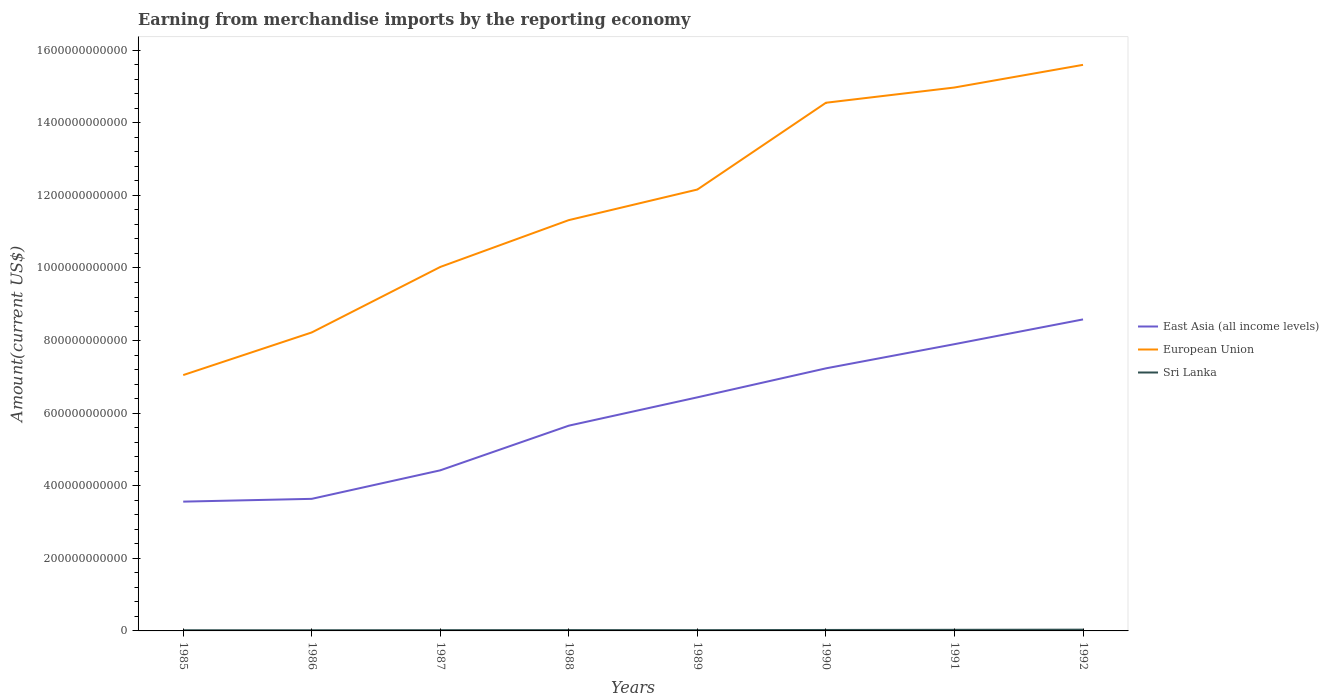Does the line corresponding to East Asia (all income levels) intersect with the line corresponding to Sri Lanka?
Keep it short and to the point. No. Is the number of lines equal to the number of legend labels?
Make the answer very short. Yes. Across all years, what is the maximum amount earned from merchandise imports in Sri Lanka?
Your response must be concise. 1.83e+09. What is the total amount earned from merchandise imports in East Asia (all income levels) in the graph?
Provide a succinct answer. -8.63e+1. What is the difference between the highest and the second highest amount earned from merchandise imports in Sri Lanka?
Provide a short and direct response. 1.64e+09. What is the difference between the highest and the lowest amount earned from merchandise imports in Sri Lanka?
Make the answer very short. 3. Is the amount earned from merchandise imports in East Asia (all income levels) strictly greater than the amount earned from merchandise imports in Sri Lanka over the years?
Ensure brevity in your answer.  No. How many lines are there?
Provide a succinct answer. 3. What is the difference between two consecutive major ticks on the Y-axis?
Provide a succinct answer. 2.00e+11. Does the graph contain any zero values?
Your response must be concise. No. Does the graph contain grids?
Keep it short and to the point. No. What is the title of the graph?
Offer a terse response. Earning from merchandise imports by the reporting economy. What is the label or title of the X-axis?
Make the answer very short. Years. What is the label or title of the Y-axis?
Offer a very short reply. Amount(current US$). What is the Amount(current US$) in East Asia (all income levels) in 1985?
Your answer should be compact. 3.56e+11. What is the Amount(current US$) of European Union in 1985?
Your response must be concise. 7.05e+11. What is the Amount(current US$) of Sri Lanka in 1985?
Provide a succinct answer. 1.83e+09. What is the Amount(current US$) in East Asia (all income levels) in 1986?
Give a very brief answer. 3.64e+11. What is the Amount(current US$) in European Union in 1986?
Your response must be concise. 8.22e+11. What is the Amount(current US$) of Sri Lanka in 1986?
Keep it short and to the point. 1.83e+09. What is the Amount(current US$) of East Asia (all income levels) in 1987?
Make the answer very short. 4.43e+11. What is the Amount(current US$) in European Union in 1987?
Provide a short and direct response. 1.00e+12. What is the Amount(current US$) of Sri Lanka in 1987?
Your answer should be very brief. 2.06e+09. What is the Amount(current US$) of East Asia (all income levels) in 1988?
Provide a succinct answer. 5.66e+11. What is the Amount(current US$) in European Union in 1988?
Your answer should be compact. 1.13e+12. What is the Amount(current US$) in Sri Lanka in 1988?
Provide a short and direct response. 2.28e+09. What is the Amount(current US$) in East Asia (all income levels) in 1989?
Make the answer very short. 6.44e+11. What is the Amount(current US$) in European Union in 1989?
Your answer should be compact. 1.22e+12. What is the Amount(current US$) in Sri Lanka in 1989?
Offer a very short reply. 2.09e+09. What is the Amount(current US$) of East Asia (all income levels) in 1990?
Keep it short and to the point. 7.23e+11. What is the Amount(current US$) in European Union in 1990?
Provide a short and direct response. 1.46e+12. What is the Amount(current US$) of Sri Lanka in 1990?
Make the answer very short. 2.64e+09. What is the Amount(current US$) in East Asia (all income levels) in 1991?
Offer a very short reply. 7.90e+11. What is the Amount(current US$) in European Union in 1991?
Your response must be concise. 1.50e+12. What is the Amount(current US$) in Sri Lanka in 1991?
Your answer should be compact. 3.06e+09. What is the Amount(current US$) of East Asia (all income levels) in 1992?
Your response must be concise. 8.58e+11. What is the Amount(current US$) in European Union in 1992?
Your answer should be compact. 1.56e+12. What is the Amount(current US$) in Sri Lanka in 1992?
Provide a succinct answer. 3.47e+09. Across all years, what is the maximum Amount(current US$) of East Asia (all income levels)?
Keep it short and to the point. 8.58e+11. Across all years, what is the maximum Amount(current US$) of European Union?
Offer a very short reply. 1.56e+12. Across all years, what is the maximum Amount(current US$) in Sri Lanka?
Your answer should be compact. 3.47e+09. Across all years, what is the minimum Amount(current US$) of East Asia (all income levels)?
Ensure brevity in your answer.  3.56e+11. Across all years, what is the minimum Amount(current US$) of European Union?
Provide a succinct answer. 7.05e+11. Across all years, what is the minimum Amount(current US$) of Sri Lanka?
Give a very brief answer. 1.83e+09. What is the total Amount(current US$) in East Asia (all income levels) in the graph?
Give a very brief answer. 4.74e+12. What is the total Amount(current US$) of European Union in the graph?
Offer a terse response. 9.39e+12. What is the total Amount(current US$) of Sri Lanka in the graph?
Make the answer very short. 1.93e+1. What is the difference between the Amount(current US$) in East Asia (all income levels) in 1985 and that in 1986?
Keep it short and to the point. -7.68e+09. What is the difference between the Amount(current US$) in European Union in 1985 and that in 1986?
Ensure brevity in your answer.  -1.17e+11. What is the difference between the Amount(current US$) in Sri Lanka in 1985 and that in 1986?
Give a very brief answer. 2.37e+06. What is the difference between the Amount(current US$) in East Asia (all income levels) in 1985 and that in 1987?
Ensure brevity in your answer.  -8.63e+1. What is the difference between the Amount(current US$) of European Union in 1985 and that in 1987?
Your answer should be compact. -2.98e+11. What is the difference between the Amount(current US$) of Sri Lanka in 1985 and that in 1987?
Offer a terse response. -2.25e+08. What is the difference between the Amount(current US$) of East Asia (all income levels) in 1985 and that in 1988?
Keep it short and to the point. -2.09e+11. What is the difference between the Amount(current US$) of European Union in 1985 and that in 1988?
Your response must be concise. -4.27e+11. What is the difference between the Amount(current US$) of Sri Lanka in 1985 and that in 1988?
Provide a short and direct response. -4.47e+08. What is the difference between the Amount(current US$) in East Asia (all income levels) in 1985 and that in 1989?
Offer a terse response. -2.87e+11. What is the difference between the Amount(current US$) of European Union in 1985 and that in 1989?
Your answer should be very brief. -5.11e+11. What is the difference between the Amount(current US$) of Sri Lanka in 1985 and that in 1989?
Give a very brief answer. -2.56e+08. What is the difference between the Amount(current US$) in East Asia (all income levels) in 1985 and that in 1990?
Ensure brevity in your answer.  -3.67e+11. What is the difference between the Amount(current US$) in European Union in 1985 and that in 1990?
Keep it short and to the point. -7.50e+11. What is the difference between the Amount(current US$) of Sri Lanka in 1985 and that in 1990?
Give a very brief answer. -8.05e+08. What is the difference between the Amount(current US$) of East Asia (all income levels) in 1985 and that in 1991?
Ensure brevity in your answer.  -4.34e+11. What is the difference between the Amount(current US$) of European Union in 1985 and that in 1991?
Offer a terse response. -7.92e+11. What is the difference between the Amount(current US$) in Sri Lanka in 1985 and that in 1991?
Offer a very short reply. -1.23e+09. What is the difference between the Amount(current US$) in East Asia (all income levels) in 1985 and that in 1992?
Your answer should be compact. -5.02e+11. What is the difference between the Amount(current US$) in European Union in 1985 and that in 1992?
Make the answer very short. -8.55e+11. What is the difference between the Amount(current US$) in Sri Lanka in 1985 and that in 1992?
Keep it short and to the point. -1.64e+09. What is the difference between the Amount(current US$) of East Asia (all income levels) in 1986 and that in 1987?
Give a very brief answer. -7.86e+1. What is the difference between the Amount(current US$) in European Union in 1986 and that in 1987?
Your answer should be compact. -1.80e+11. What is the difference between the Amount(current US$) of Sri Lanka in 1986 and that in 1987?
Your response must be concise. -2.27e+08. What is the difference between the Amount(current US$) of East Asia (all income levels) in 1986 and that in 1988?
Offer a terse response. -2.02e+11. What is the difference between the Amount(current US$) of European Union in 1986 and that in 1988?
Offer a terse response. -3.10e+11. What is the difference between the Amount(current US$) in Sri Lanka in 1986 and that in 1988?
Your answer should be very brief. -4.49e+08. What is the difference between the Amount(current US$) of East Asia (all income levels) in 1986 and that in 1989?
Provide a short and direct response. -2.80e+11. What is the difference between the Amount(current US$) of European Union in 1986 and that in 1989?
Offer a terse response. -3.94e+11. What is the difference between the Amount(current US$) in Sri Lanka in 1986 and that in 1989?
Offer a very short reply. -2.58e+08. What is the difference between the Amount(current US$) in East Asia (all income levels) in 1986 and that in 1990?
Ensure brevity in your answer.  -3.60e+11. What is the difference between the Amount(current US$) of European Union in 1986 and that in 1990?
Offer a very short reply. -6.33e+11. What is the difference between the Amount(current US$) of Sri Lanka in 1986 and that in 1990?
Give a very brief answer. -8.07e+08. What is the difference between the Amount(current US$) in East Asia (all income levels) in 1986 and that in 1991?
Make the answer very short. -4.26e+11. What is the difference between the Amount(current US$) of European Union in 1986 and that in 1991?
Give a very brief answer. -6.75e+11. What is the difference between the Amount(current US$) in Sri Lanka in 1986 and that in 1991?
Provide a short and direct response. -1.23e+09. What is the difference between the Amount(current US$) in East Asia (all income levels) in 1986 and that in 1992?
Provide a succinct answer. -4.94e+11. What is the difference between the Amount(current US$) of European Union in 1986 and that in 1992?
Your response must be concise. -7.37e+11. What is the difference between the Amount(current US$) in Sri Lanka in 1986 and that in 1992?
Your response must be concise. -1.64e+09. What is the difference between the Amount(current US$) in East Asia (all income levels) in 1987 and that in 1988?
Your answer should be very brief. -1.23e+11. What is the difference between the Amount(current US$) of European Union in 1987 and that in 1988?
Your answer should be compact. -1.29e+11. What is the difference between the Amount(current US$) in Sri Lanka in 1987 and that in 1988?
Offer a terse response. -2.22e+08. What is the difference between the Amount(current US$) of East Asia (all income levels) in 1987 and that in 1989?
Your response must be concise. -2.01e+11. What is the difference between the Amount(current US$) in European Union in 1987 and that in 1989?
Make the answer very short. -2.13e+11. What is the difference between the Amount(current US$) in Sri Lanka in 1987 and that in 1989?
Give a very brief answer. -3.11e+07. What is the difference between the Amount(current US$) in East Asia (all income levels) in 1987 and that in 1990?
Keep it short and to the point. -2.81e+11. What is the difference between the Amount(current US$) in European Union in 1987 and that in 1990?
Ensure brevity in your answer.  -4.52e+11. What is the difference between the Amount(current US$) in Sri Lanka in 1987 and that in 1990?
Make the answer very short. -5.80e+08. What is the difference between the Amount(current US$) in East Asia (all income levels) in 1987 and that in 1991?
Make the answer very short. -3.48e+11. What is the difference between the Amount(current US$) of European Union in 1987 and that in 1991?
Your answer should be very brief. -4.94e+11. What is the difference between the Amount(current US$) in Sri Lanka in 1987 and that in 1991?
Your response must be concise. -1.00e+09. What is the difference between the Amount(current US$) in East Asia (all income levels) in 1987 and that in 1992?
Provide a short and direct response. -4.16e+11. What is the difference between the Amount(current US$) of European Union in 1987 and that in 1992?
Provide a succinct answer. -5.57e+11. What is the difference between the Amount(current US$) of Sri Lanka in 1987 and that in 1992?
Keep it short and to the point. -1.42e+09. What is the difference between the Amount(current US$) in East Asia (all income levels) in 1988 and that in 1989?
Give a very brief answer. -7.80e+1. What is the difference between the Amount(current US$) in European Union in 1988 and that in 1989?
Provide a short and direct response. -8.42e+1. What is the difference between the Amount(current US$) in Sri Lanka in 1988 and that in 1989?
Keep it short and to the point. 1.91e+08. What is the difference between the Amount(current US$) in East Asia (all income levels) in 1988 and that in 1990?
Offer a terse response. -1.58e+11. What is the difference between the Amount(current US$) of European Union in 1988 and that in 1990?
Your response must be concise. -3.23e+11. What is the difference between the Amount(current US$) of Sri Lanka in 1988 and that in 1990?
Give a very brief answer. -3.58e+08. What is the difference between the Amount(current US$) in East Asia (all income levels) in 1988 and that in 1991?
Offer a terse response. -2.25e+11. What is the difference between the Amount(current US$) in European Union in 1988 and that in 1991?
Ensure brevity in your answer.  -3.65e+11. What is the difference between the Amount(current US$) in Sri Lanka in 1988 and that in 1991?
Provide a short and direct response. -7.82e+08. What is the difference between the Amount(current US$) in East Asia (all income levels) in 1988 and that in 1992?
Your answer should be very brief. -2.93e+11. What is the difference between the Amount(current US$) in European Union in 1988 and that in 1992?
Offer a terse response. -4.28e+11. What is the difference between the Amount(current US$) in Sri Lanka in 1988 and that in 1992?
Provide a succinct answer. -1.19e+09. What is the difference between the Amount(current US$) of East Asia (all income levels) in 1989 and that in 1990?
Your answer should be compact. -7.99e+1. What is the difference between the Amount(current US$) of European Union in 1989 and that in 1990?
Keep it short and to the point. -2.39e+11. What is the difference between the Amount(current US$) in Sri Lanka in 1989 and that in 1990?
Make the answer very short. -5.49e+08. What is the difference between the Amount(current US$) in East Asia (all income levels) in 1989 and that in 1991?
Offer a terse response. -1.47e+11. What is the difference between the Amount(current US$) in European Union in 1989 and that in 1991?
Provide a short and direct response. -2.81e+11. What is the difference between the Amount(current US$) of Sri Lanka in 1989 and that in 1991?
Keep it short and to the point. -9.74e+08. What is the difference between the Amount(current US$) in East Asia (all income levels) in 1989 and that in 1992?
Keep it short and to the point. -2.15e+11. What is the difference between the Amount(current US$) in European Union in 1989 and that in 1992?
Your answer should be very brief. -3.44e+11. What is the difference between the Amount(current US$) of Sri Lanka in 1989 and that in 1992?
Offer a terse response. -1.39e+09. What is the difference between the Amount(current US$) in East Asia (all income levels) in 1990 and that in 1991?
Your response must be concise. -6.66e+1. What is the difference between the Amount(current US$) of European Union in 1990 and that in 1991?
Your response must be concise. -4.20e+1. What is the difference between the Amount(current US$) of Sri Lanka in 1990 and that in 1991?
Keep it short and to the point. -4.25e+08. What is the difference between the Amount(current US$) in East Asia (all income levels) in 1990 and that in 1992?
Your answer should be very brief. -1.35e+11. What is the difference between the Amount(current US$) of European Union in 1990 and that in 1992?
Ensure brevity in your answer.  -1.04e+11. What is the difference between the Amount(current US$) in Sri Lanka in 1990 and that in 1992?
Provide a short and direct response. -8.36e+08. What is the difference between the Amount(current US$) of East Asia (all income levels) in 1991 and that in 1992?
Offer a terse response. -6.82e+1. What is the difference between the Amount(current US$) of European Union in 1991 and that in 1992?
Offer a terse response. -6.24e+1. What is the difference between the Amount(current US$) of Sri Lanka in 1991 and that in 1992?
Ensure brevity in your answer.  -4.12e+08. What is the difference between the Amount(current US$) of East Asia (all income levels) in 1985 and the Amount(current US$) of European Union in 1986?
Ensure brevity in your answer.  -4.66e+11. What is the difference between the Amount(current US$) in East Asia (all income levels) in 1985 and the Amount(current US$) in Sri Lanka in 1986?
Keep it short and to the point. 3.54e+11. What is the difference between the Amount(current US$) of European Union in 1985 and the Amount(current US$) of Sri Lanka in 1986?
Your response must be concise. 7.03e+11. What is the difference between the Amount(current US$) of East Asia (all income levels) in 1985 and the Amount(current US$) of European Union in 1987?
Keep it short and to the point. -6.47e+11. What is the difference between the Amount(current US$) of East Asia (all income levels) in 1985 and the Amount(current US$) of Sri Lanka in 1987?
Ensure brevity in your answer.  3.54e+11. What is the difference between the Amount(current US$) of European Union in 1985 and the Amount(current US$) of Sri Lanka in 1987?
Your answer should be very brief. 7.03e+11. What is the difference between the Amount(current US$) of East Asia (all income levels) in 1985 and the Amount(current US$) of European Union in 1988?
Give a very brief answer. -7.76e+11. What is the difference between the Amount(current US$) in East Asia (all income levels) in 1985 and the Amount(current US$) in Sri Lanka in 1988?
Your answer should be compact. 3.54e+11. What is the difference between the Amount(current US$) in European Union in 1985 and the Amount(current US$) in Sri Lanka in 1988?
Ensure brevity in your answer.  7.03e+11. What is the difference between the Amount(current US$) in East Asia (all income levels) in 1985 and the Amount(current US$) in European Union in 1989?
Make the answer very short. -8.60e+11. What is the difference between the Amount(current US$) of East Asia (all income levels) in 1985 and the Amount(current US$) of Sri Lanka in 1989?
Keep it short and to the point. 3.54e+11. What is the difference between the Amount(current US$) of European Union in 1985 and the Amount(current US$) of Sri Lanka in 1989?
Provide a succinct answer. 7.03e+11. What is the difference between the Amount(current US$) in East Asia (all income levels) in 1985 and the Amount(current US$) in European Union in 1990?
Give a very brief answer. -1.10e+12. What is the difference between the Amount(current US$) in East Asia (all income levels) in 1985 and the Amount(current US$) in Sri Lanka in 1990?
Your answer should be very brief. 3.54e+11. What is the difference between the Amount(current US$) in European Union in 1985 and the Amount(current US$) in Sri Lanka in 1990?
Give a very brief answer. 7.02e+11. What is the difference between the Amount(current US$) of East Asia (all income levels) in 1985 and the Amount(current US$) of European Union in 1991?
Provide a succinct answer. -1.14e+12. What is the difference between the Amount(current US$) in East Asia (all income levels) in 1985 and the Amount(current US$) in Sri Lanka in 1991?
Make the answer very short. 3.53e+11. What is the difference between the Amount(current US$) in European Union in 1985 and the Amount(current US$) in Sri Lanka in 1991?
Your answer should be compact. 7.02e+11. What is the difference between the Amount(current US$) of East Asia (all income levels) in 1985 and the Amount(current US$) of European Union in 1992?
Ensure brevity in your answer.  -1.20e+12. What is the difference between the Amount(current US$) in East Asia (all income levels) in 1985 and the Amount(current US$) in Sri Lanka in 1992?
Your answer should be compact. 3.53e+11. What is the difference between the Amount(current US$) in European Union in 1985 and the Amount(current US$) in Sri Lanka in 1992?
Offer a terse response. 7.01e+11. What is the difference between the Amount(current US$) of East Asia (all income levels) in 1986 and the Amount(current US$) of European Union in 1987?
Provide a short and direct response. -6.39e+11. What is the difference between the Amount(current US$) in East Asia (all income levels) in 1986 and the Amount(current US$) in Sri Lanka in 1987?
Provide a succinct answer. 3.62e+11. What is the difference between the Amount(current US$) in European Union in 1986 and the Amount(current US$) in Sri Lanka in 1987?
Provide a short and direct response. 8.20e+11. What is the difference between the Amount(current US$) of East Asia (all income levels) in 1986 and the Amount(current US$) of European Union in 1988?
Provide a succinct answer. -7.68e+11. What is the difference between the Amount(current US$) of East Asia (all income levels) in 1986 and the Amount(current US$) of Sri Lanka in 1988?
Offer a very short reply. 3.62e+11. What is the difference between the Amount(current US$) in European Union in 1986 and the Amount(current US$) in Sri Lanka in 1988?
Ensure brevity in your answer.  8.20e+11. What is the difference between the Amount(current US$) of East Asia (all income levels) in 1986 and the Amount(current US$) of European Union in 1989?
Your answer should be very brief. -8.52e+11. What is the difference between the Amount(current US$) in East Asia (all income levels) in 1986 and the Amount(current US$) in Sri Lanka in 1989?
Your answer should be compact. 3.62e+11. What is the difference between the Amount(current US$) in European Union in 1986 and the Amount(current US$) in Sri Lanka in 1989?
Give a very brief answer. 8.20e+11. What is the difference between the Amount(current US$) of East Asia (all income levels) in 1986 and the Amount(current US$) of European Union in 1990?
Your answer should be compact. -1.09e+12. What is the difference between the Amount(current US$) of East Asia (all income levels) in 1986 and the Amount(current US$) of Sri Lanka in 1990?
Provide a short and direct response. 3.61e+11. What is the difference between the Amount(current US$) in European Union in 1986 and the Amount(current US$) in Sri Lanka in 1990?
Offer a very short reply. 8.20e+11. What is the difference between the Amount(current US$) of East Asia (all income levels) in 1986 and the Amount(current US$) of European Union in 1991?
Your answer should be very brief. -1.13e+12. What is the difference between the Amount(current US$) in East Asia (all income levels) in 1986 and the Amount(current US$) in Sri Lanka in 1991?
Ensure brevity in your answer.  3.61e+11. What is the difference between the Amount(current US$) in European Union in 1986 and the Amount(current US$) in Sri Lanka in 1991?
Your response must be concise. 8.19e+11. What is the difference between the Amount(current US$) in East Asia (all income levels) in 1986 and the Amount(current US$) in European Union in 1992?
Give a very brief answer. -1.20e+12. What is the difference between the Amount(current US$) in East Asia (all income levels) in 1986 and the Amount(current US$) in Sri Lanka in 1992?
Your response must be concise. 3.60e+11. What is the difference between the Amount(current US$) in European Union in 1986 and the Amount(current US$) in Sri Lanka in 1992?
Offer a terse response. 8.19e+11. What is the difference between the Amount(current US$) in East Asia (all income levels) in 1987 and the Amount(current US$) in European Union in 1988?
Give a very brief answer. -6.89e+11. What is the difference between the Amount(current US$) in East Asia (all income levels) in 1987 and the Amount(current US$) in Sri Lanka in 1988?
Offer a very short reply. 4.40e+11. What is the difference between the Amount(current US$) of European Union in 1987 and the Amount(current US$) of Sri Lanka in 1988?
Make the answer very short. 1.00e+12. What is the difference between the Amount(current US$) of East Asia (all income levels) in 1987 and the Amount(current US$) of European Union in 1989?
Offer a terse response. -7.74e+11. What is the difference between the Amount(current US$) of East Asia (all income levels) in 1987 and the Amount(current US$) of Sri Lanka in 1989?
Ensure brevity in your answer.  4.40e+11. What is the difference between the Amount(current US$) in European Union in 1987 and the Amount(current US$) in Sri Lanka in 1989?
Keep it short and to the point. 1.00e+12. What is the difference between the Amount(current US$) of East Asia (all income levels) in 1987 and the Amount(current US$) of European Union in 1990?
Provide a succinct answer. -1.01e+12. What is the difference between the Amount(current US$) of East Asia (all income levels) in 1987 and the Amount(current US$) of Sri Lanka in 1990?
Your answer should be compact. 4.40e+11. What is the difference between the Amount(current US$) in European Union in 1987 and the Amount(current US$) in Sri Lanka in 1990?
Keep it short and to the point. 1.00e+12. What is the difference between the Amount(current US$) of East Asia (all income levels) in 1987 and the Amount(current US$) of European Union in 1991?
Give a very brief answer. -1.05e+12. What is the difference between the Amount(current US$) of East Asia (all income levels) in 1987 and the Amount(current US$) of Sri Lanka in 1991?
Offer a terse response. 4.39e+11. What is the difference between the Amount(current US$) in European Union in 1987 and the Amount(current US$) in Sri Lanka in 1991?
Your answer should be very brief. 1.00e+12. What is the difference between the Amount(current US$) in East Asia (all income levels) in 1987 and the Amount(current US$) in European Union in 1992?
Provide a succinct answer. -1.12e+12. What is the difference between the Amount(current US$) of East Asia (all income levels) in 1987 and the Amount(current US$) of Sri Lanka in 1992?
Offer a very short reply. 4.39e+11. What is the difference between the Amount(current US$) in European Union in 1987 and the Amount(current US$) in Sri Lanka in 1992?
Provide a short and direct response. 9.99e+11. What is the difference between the Amount(current US$) in East Asia (all income levels) in 1988 and the Amount(current US$) in European Union in 1989?
Make the answer very short. -6.51e+11. What is the difference between the Amount(current US$) in East Asia (all income levels) in 1988 and the Amount(current US$) in Sri Lanka in 1989?
Your answer should be compact. 5.64e+11. What is the difference between the Amount(current US$) of European Union in 1988 and the Amount(current US$) of Sri Lanka in 1989?
Offer a terse response. 1.13e+12. What is the difference between the Amount(current US$) in East Asia (all income levels) in 1988 and the Amount(current US$) in European Union in 1990?
Offer a very short reply. -8.90e+11. What is the difference between the Amount(current US$) of East Asia (all income levels) in 1988 and the Amount(current US$) of Sri Lanka in 1990?
Ensure brevity in your answer.  5.63e+11. What is the difference between the Amount(current US$) in European Union in 1988 and the Amount(current US$) in Sri Lanka in 1990?
Make the answer very short. 1.13e+12. What is the difference between the Amount(current US$) of East Asia (all income levels) in 1988 and the Amount(current US$) of European Union in 1991?
Offer a terse response. -9.32e+11. What is the difference between the Amount(current US$) of East Asia (all income levels) in 1988 and the Amount(current US$) of Sri Lanka in 1991?
Provide a short and direct response. 5.63e+11. What is the difference between the Amount(current US$) of European Union in 1988 and the Amount(current US$) of Sri Lanka in 1991?
Your answer should be compact. 1.13e+12. What is the difference between the Amount(current US$) in East Asia (all income levels) in 1988 and the Amount(current US$) in European Union in 1992?
Make the answer very short. -9.94e+11. What is the difference between the Amount(current US$) of East Asia (all income levels) in 1988 and the Amount(current US$) of Sri Lanka in 1992?
Your answer should be very brief. 5.62e+11. What is the difference between the Amount(current US$) in European Union in 1988 and the Amount(current US$) in Sri Lanka in 1992?
Your answer should be compact. 1.13e+12. What is the difference between the Amount(current US$) of East Asia (all income levels) in 1989 and the Amount(current US$) of European Union in 1990?
Offer a terse response. -8.12e+11. What is the difference between the Amount(current US$) in East Asia (all income levels) in 1989 and the Amount(current US$) in Sri Lanka in 1990?
Your answer should be very brief. 6.41e+11. What is the difference between the Amount(current US$) in European Union in 1989 and the Amount(current US$) in Sri Lanka in 1990?
Provide a succinct answer. 1.21e+12. What is the difference between the Amount(current US$) of East Asia (all income levels) in 1989 and the Amount(current US$) of European Union in 1991?
Give a very brief answer. -8.54e+11. What is the difference between the Amount(current US$) of East Asia (all income levels) in 1989 and the Amount(current US$) of Sri Lanka in 1991?
Ensure brevity in your answer.  6.41e+11. What is the difference between the Amount(current US$) of European Union in 1989 and the Amount(current US$) of Sri Lanka in 1991?
Give a very brief answer. 1.21e+12. What is the difference between the Amount(current US$) of East Asia (all income levels) in 1989 and the Amount(current US$) of European Union in 1992?
Your response must be concise. -9.16e+11. What is the difference between the Amount(current US$) of East Asia (all income levels) in 1989 and the Amount(current US$) of Sri Lanka in 1992?
Make the answer very short. 6.40e+11. What is the difference between the Amount(current US$) of European Union in 1989 and the Amount(current US$) of Sri Lanka in 1992?
Your answer should be very brief. 1.21e+12. What is the difference between the Amount(current US$) in East Asia (all income levels) in 1990 and the Amount(current US$) in European Union in 1991?
Offer a terse response. -7.74e+11. What is the difference between the Amount(current US$) in East Asia (all income levels) in 1990 and the Amount(current US$) in Sri Lanka in 1991?
Make the answer very short. 7.20e+11. What is the difference between the Amount(current US$) in European Union in 1990 and the Amount(current US$) in Sri Lanka in 1991?
Make the answer very short. 1.45e+12. What is the difference between the Amount(current US$) in East Asia (all income levels) in 1990 and the Amount(current US$) in European Union in 1992?
Provide a succinct answer. -8.36e+11. What is the difference between the Amount(current US$) in East Asia (all income levels) in 1990 and the Amount(current US$) in Sri Lanka in 1992?
Ensure brevity in your answer.  7.20e+11. What is the difference between the Amount(current US$) of European Union in 1990 and the Amount(current US$) of Sri Lanka in 1992?
Give a very brief answer. 1.45e+12. What is the difference between the Amount(current US$) of East Asia (all income levels) in 1991 and the Amount(current US$) of European Union in 1992?
Your response must be concise. -7.70e+11. What is the difference between the Amount(current US$) of East Asia (all income levels) in 1991 and the Amount(current US$) of Sri Lanka in 1992?
Your answer should be compact. 7.87e+11. What is the difference between the Amount(current US$) of European Union in 1991 and the Amount(current US$) of Sri Lanka in 1992?
Offer a terse response. 1.49e+12. What is the average Amount(current US$) of East Asia (all income levels) per year?
Ensure brevity in your answer.  5.93e+11. What is the average Amount(current US$) in European Union per year?
Ensure brevity in your answer.  1.17e+12. What is the average Amount(current US$) in Sri Lanka per year?
Your answer should be compact. 2.41e+09. In the year 1985, what is the difference between the Amount(current US$) of East Asia (all income levels) and Amount(current US$) of European Union?
Provide a short and direct response. -3.49e+11. In the year 1985, what is the difference between the Amount(current US$) in East Asia (all income levels) and Amount(current US$) in Sri Lanka?
Give a very brief answer. 3.54e+11. In the year 1985, what is the difference between the Amount(current US$) of European Union and Amount(current US$) of Sri Lanka?
Make the answer very short. 7.03e+11. In the year 1986, what is the difference between the Amount(current US$) in East Asia (all income levels) and Amount(current US$) in European Union?
Provide a succinct answer. -4.58e+11. In the year 1986, what is the difference between the Amount(current US$) of East Asia (all income levels) and Amount(current US$) of Sri Lanka?
Give a very brief answer. 3.62e+11. In the year 1986, what is the difference between the Amount(current US$) of European Union and Amount(current US$) of Sri Lanka?
Provide a succinct answer. 8.21e+11. In the year 1987, what is the difference between the Amount(current US$) of East Asia (all income levels) and Amount(current US$) of European Union?
Your answer should be compact. -5.60e+11. In the year 1987, what is the difference between the Amount(current US$) of East Asia (all income levels) and Amount(current US$) of Sri Lanka?
Provide a succinct answer. 4.40e+11. In the year 1987, what is the difference between the Amount(current US$) in European Union and Amount(current US$) in Sri Lanka?
Your answer should be compact. 1.00e+12. In the year 1988, what is the difference between the Amount(current US$) in East Asia (all income levels) and Amount(current US$) in European Union?
Ensure brevity in your answer.  -5.66e+11. In the year 1988, what is the difference between the Amount(current US$) in East Asia (all income levels) and Amount(current US$) in Sri Lanka?
Offer a very short reply. 5.63e+11. In the year 1988, what is the difference between the Amount(current US$) of European Union and Amount(current US$) of Sri Lanka?
Make the answer very short. 1.13e+12. In the year 1989, what is the difference between the Amount(current US$) in East Asia (all income levels) and Amount(current US$) in European Union?
Your answer should be compact. -5.73e+11. In the year 1989, what is the difference between the Amount(current US$) of East Asia (all income levels) and Amount(current US$) of Sri Lanka?
Your answer should be very brief. 6.42e+11. In the year 1989, what is the difference between the Amount(current US$) in European Union and Amount(current US$) in Sri Lanka?
Keep it short and to the point. 1.21e+12. In the year 1990, what is the difference between the Amount(current US$) of East Asia (all income levels) and Amount(current US$) of European Union?
Your answer should be very brief. -7.32e+11. In the year 1990, what is the difference between the Amount(current US$) of East Asia (all income levels) and Amount(current US$) of Sri Lanka?
Offer a very short reply. 7.21e+11. In the year 1990, what is the difference between the Amount(current US$) in European Union and Amount(current US$) in Sri Lanka?
Make the answer very short. 1.45e+12. In the year 1991, what is the difference between the Amount(current US$) of East Asia (all income levels) and Amount(current US$) of European Union?
Your answer should be compact. -7.07e+11. In the year 1991, what is the difference between the Amount(current US$) in East Asia (all income levels) and Amount(current US$) in Sri Lanka?
Ensure brevity in your answer.  7.87e+11. In the year 1991, what is the difference between the Amount(current US$) of European Union and Amount(current US$) of Sri Lanka?
Provide a short and direct response. 1.49e+12. In the year 1992, what is the difference between the Amount(current US$) of East Asia (all income levels) and Amount(current US$) of European Union?
Your answer should be very brief. -7.01e+11. In the year 1992, what is the difference between the Amount(current US$) in East Asia (all income levels) and Amount(current US$) in Sri Lanka?
Your answer should be compact. 8.55e+11. In the year 1992, what is the difference between the Amount(current US$) in European Union and Amount(current US$) in Sri Lanka?
Your answer should be very brief. 1.56e+12. What is the ratio of the Amount(current US$) of East Asia (all income levels) in 1985 to that in 1986?
Offer a very short reply. 0.98. What is the ratio of the Amount(current US$) in European Union in 1985 to that in 1986?
Your response must be concise. 0.86. What is the ratio of the Amount(current US$) of East Asia (all income levels) in 1985 to that in 1987?
Give a very brief answer. 0.81. What is the ratio of the Amount(current US$) in European Union in 1985 to that in 1987?
Provide a succinct answer. 0.7. What is the ratio of the Amount(current US$) in Sri Lanka in 1985 to that in 1987?
Your answer should be very brief. 0.89. What is the ratio of the Amount(current US$) of East Asia (all income levels) in 1985 to that in 1988?
Your answer should be very brief. 0.63. What is the ratio of the Amount(current US$) in European Union in 1985 to that in 1988?
Offer a very short reply. 0.62. What is the ratio of the Amount(current US$) in Sri Lanka in 1985 to that in 1988?
Make the answer very short. 0.8. What is the ratio of the Amount(current US$) of East Asia (all income levels) in 1985 to that in 1989?
Provide a succinct answer. 0.55. What is the ratio of the Amount(current US$) of European Union in 1985 to that in 1989?
Your response must be concise. 0.58. What is the ratio of the Amount(current US$) of Sri Lanka in 1985 to that in 1989?
Your response must be concise. 0.88. What is the ratio of the Amount(current US$) of East Asia (all income levels) in 1985 to that in 1990?
Keep it short and to the point. 0.49. What is the ratio of the Amount(current US$) in European Union in 1985 to that in 1990?
Keep it short and to the point. 0.48. What is the ratio of the Amount(current US$) of Sri Lanka in 1985 to that in 1990?
Give a very brief answer. 0.69. What is the ratio of the Amount(current US$) of East Asia (all income levels) in 1985 to that in 1991?
Provide a short and direct response. 0.45. What is the ratio of the Amount(current US$) of European Union in 1985 to that in 1991?
Keep it short and to the point. 0.47. What is the ratio of the Amount(current US$) of Sri Lanka in 1985 to that in 1991?
Offer a terse response. 0.6. What is the ratio of the Amount(current US$) in East Asia (all income levels) in 1985 to that in 1992?
Provide a short and direct response. 0.41. What is the ratio of the Amount(current US$) in European Union in 1985 to that in 1992?
Ensure brevity in your answer.  0.45. What is the ratio of the Amount(current US$) in Sri Lanka in 1985 to that in 1992?
Your answer should be compact. 0.53. What is the ratio of the Amount(current US$) of East Asia (all income levels) in 1986 to that in 1987?
Give a very brief answer. 0.82. What is the ratio of the Amount(current US$) of European Union in 1986 to that in 1987?
Keep it short and to the point. 0.82. What is the ratio of the Amount(current US$) of Sri Lanka in 1986 to that in 1987?
Give a very brief answer. 0.89. What is the ratio of the Amount(current US$) of East Asia (all income levels) in 1986 to that in 1988?
Provide a short and direct response. 0.64. What is the ratio of the Amount(current US$) of European Union in 1986 to that in 1988?
Your answer should be very brief. 0.73. What is the ratio of the Amount(current US$) of Sri Lanka in 1986 to that in 1988?
Ensure brevity in your answer.  0.8. What is the ratio of the Amount(current US$) in East Asia (all income levels) in 1986 to that in 1989?
Provide a short and direct response. 0.57. What is the ratio of the Amount(current US$) in European Union in 1986 to that in 1989?
Offer a very short reply. 0.68. What is the ratio of the Amount(current US$) of Sri Lanka in 1986 to that in 1989?
Make the answer very short. 0.88. What is the ratio of the Amount(current US$) of East Asia (all income levels) in 1986 to that in 1990?
Give a very brief answer. 0.5. What is the ratio of the Amount(current US$) of European Union in 1986 to that in 1990?
Provide a short and direct response. 0.57. What is the ratio of the Amount(current US$) in Sri Lanka in 1986 to that in 1990?
Offer a terse response. 0.69. What is the ratio of the Amount(current US$) in East Asia (all income levels) in 1986 to that in 1991?
Your answer should be very brief. 0.46. What is the ratio of the Amount(current US$) of European Union in 1986 to that in 1991?
Offer a very short reply. 0.55. What is the ratio of the Amount(current US$) of Sri Lanka in 1986 to that in 1991?
Your answer should be very brief. 0.6. What is the ratio of the Amount(current US$) in East Asia (all income levels) in 1986 to that in 1992?
Make the answer very short. 0.42. What is the ratio of the Amount(current US$) in European Union in 1986 to that in 1992?
Keep it short and to the point. 0.53. What is the ratio of the Amount(current US$) in Sri Lanka in 1986 to that in 1992?
Provide a short and direct response. 0.53. What is the ratio of the Amount(current US$) of East Asia (all income levels) in 1987 to that in 1988?
Offer a terse response. 0.78. What is the ratio of the Amount(current US$) of European Union in 1987 to that in 1988?
Give a very brief answer. 0.89. What is the ratio of the Amount(current US$) of Sri Lanka in 1987 to that in 1988?
Provide a succinct answer. 0.9. What is the ratio of the Amount(current US$) of East Asia (all income levels) in 1987 to that in 1989?
Your answer should be compact. 0.69. What is the ratio of the Amount(current US$) in European Union in 1987 to that in 1989?
Your answer should be very brief. 0.82. What is the ratio of the Amount(current US$) in Sri Lanka in 1987 to that in 1989?
Your answer should be compact. 0.99. What is the ratio of the Amount(current US$) in East Asia (all income levels) in 1987 to that in 1990?
Give a very brief answer. 0.61. What is the ratio of the Amount(current US$) of European Union in 1987 to that in 1990?
Offer a very short reply. 0.69. What is the ratio of the Amount(current US$) in Sri Lanka in 1987 to that in 1990?
Make the answer very short. 0.78. What is the ratio of the Amount(current US$) of East Asia (all income levels) in 1987 to that in 1991?
Give a very brief answer. 0.56. What is the ratio of the Amount(current US$) in European Union in 1987 to that in 1991?
Your answer should be very brief. 0.67. What is the ratio of the Amount(current US$) in Sri Lanka in 1987 to that in 1991?
Keep it short and to the point. 0.67. What is the ratio of the Amount(current US$) of East Asia (all income levels) in 1987 to that in 1992?
Your response must be concise. 0.52. What is the ratio of the Amount(current US$) in European Union in 1987 to that in 1992?
Keep it short and to the point. 0.64. What is the ratio of the Amount(current US$) in Sri Lanka in 1987 to that in 1992?
Offer a very short reply. 0.59. What is the ratio of the Amount(current US$) in East Asia (all income levels) in 1988 to that in 1989?
Ensure brevity in your answer.  0.88. What is the ratio of the Amount(current US$) in European Union in 1988 to that in 1989?
Give a very brief answer. 0.93. What is the ratio of the Amount(current US$) of Sri Lanka in 1988 to that in 1989?
Offer a very short reply. 1.09. What is the ratio of the Amount(current US$) of East Asia (all income levels) in 1988 to that in 1990?
Your response must be concise. 0.78. What is the ratio of the Amount(current US$) of European Union in 1988 to that in 1990?
Offer a very short reply. 0.78. What is the ratio of the Amount(current US$) in Sri Lanka in 1988 to that in 1990?
Your answer should be compact. 0.86. What is the ratio of the Amount(current US$) in East Asia (all income levels) in 1988 to that in 1991?
Your answer should be compact. 0.72. What is the ratio of the Amount(current US$) in European Union in 1988 to that in 1991?
Offer a terse response. 0.76. What is the ratio of the Amount(current US$) of Sri Lanka in 1988 to that in 1991?
Ensure brevity in your answer.  0.74. What is the ratio of the Amount(current US$) of East Asia (all income levels) in 1988 to that in 1992?
Provide a short and direct response. 0.66. What is the ratio of the Amount(current US$) in European Union in 1988 to that in 1992?
Keep it short and to the point. 0.73. What is the ratio of the Amount(current US$) of Sri Lanka in 1988 to that in 1992?
Ensure brevity in your answer.  0.66. What is the ratio of the Amount(current US$) in East Asia (all income levels) in 1989 to that in 1990?
Provide a succinct answer. 0.89. What is the ratio of the Amount(current US$) of European Union in 1989 to that in 1990?
Make the answer very short. 0.84. What is the ratio of the Amount(current US$) in Sri Lanka in 1989 to that in 1990?
Your answer should be very brief. 0.79. What is the ratio of the Amount(current US$) in East Asia (all income levels) in 1989 to that in 1991?
Ensure brevity in your answer.  0.81. What is the ratio of the Amount(current US$) in European Union in 1989 to that in 1991?
Provide a succinct answer. 0.81. What is the ratio of the Amount(current US$) of Sri Lanka in 1989 to that in 1991?
Offer a terse response. 0.68. What is the ratio of the Amount(current US$) of East Asia (all income levels) in 1989 to that in 1992?
Your response must be concise. 0.75. What is the ratio of the Amount(current US$) in European Union in 1989 to that in 1992?
Provide a succinct answer. 0.78. What is the ratio of the Amount(current US$) of Sri Lanka in 1989 to that in 1992?
Offer a terse response. 0.6. What is the ratio of the Amount(current US$) in East Asia (all income levels) in 1990 to that in 1991?
Provide a short and direct response. 0.92. What is the ratio of the Amount(current US$) in European Union in 1990 to that in 1991?
Your answer should be compact. 0.97. What is the ratio of the Amount(current US$) of Sri Lanka in 1990 to that in 1991?
Your response must be concise. 0.86. What is the ratio of the Amount(current US$) of East Asia (all income levels) in 1990 to that in 1992?
Your answer should be compact. 0.84. What is the ratio of the Amount(current US$) in European Union in 1990 to that in 1992?
Provide a short and direct response. 0.93. What is the ratio of the Amount(current US$) in Sri Lanka in 1990 to that in 1992?
Your answer should be compact. 0.76. What is the ratio of the Amount(current US$) in East Asia (all income levels) in 1991 to that in 1992?
Provide a succinct answer. 0.92. What is the ratio of the Amount(current US$) of European Union in 1991 to that in 1992?
Offer a very short reply. 0.96. What is the ratio of the Amount(current US$) of Sri Lanka in 1991 to that in 1992?
Give a very brief answer. 0.88. What is the difference between the highest and the second highest Amount(current US$) of East Asia (all income levels)?
Ensure brevity in your answer.  6.82e+1. What is the difference between the highest and the second highest Amount(current US$) in European Union?
Your response must be concise. 6.24e+1. What is the difference between the highest and the second highest Amount(current US$) of Sri Lanka?
Give a very brief answer. 4.12e+08. What is the difference between the highest and the lowest Amount(current US$) in East Asia (all income levels)?
Make the answer very short. 5.02e+11. What is the difference between the highest and the lowest Amount(current US$) in European Union?
Give a very brief answer. 8.55e+11. What is the difference between the highest and the lowest Amount(current US$) in Sri Lanka?
Your answer should be compact. 1.64e+09. 